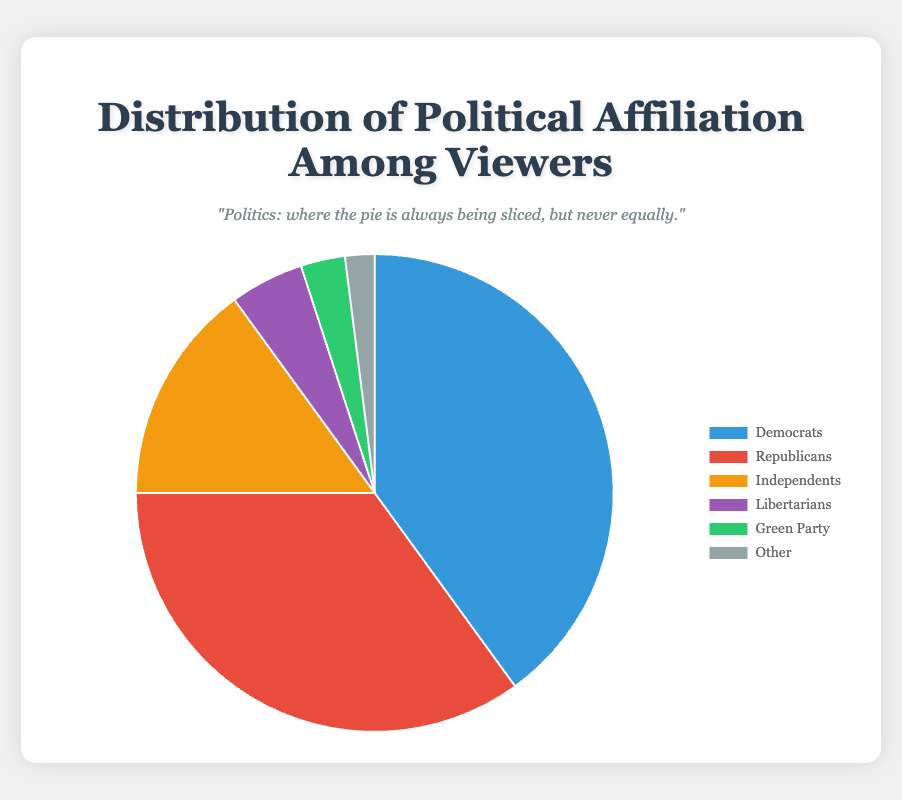Which political affiliation has the highest percentage of viewers? By observing the pie chart, the segment labeled "Democrats" takes up the largest proportion of the chart. Therefore, Democrats have the highest percentage of viewers.
Answer: Democrats Which political affiliation has the lowest percentage of viewers? The smallest segment in the pie chart is labeled "Other," indicating that it has the lowest percentage of viewers.
Answer: Other What is the combined percentage of viewers who identify as Independents or Libertarians? The percentage for Independents is 15%, and for Libertarians, it is 5%. Adding these together, we get 15 + 5 = 20%.
Answer: 20% How much greater is the percentage of Democrats compared to Republicans? The Democrats have a 40% share, and the Republicans have a 35% share. The difference is 40 - 35 = 5%.
Answer: 5% What is the total percentage of viewers that do not identify as Democrats or Republicans? To find the percentage of viewers who are not Democrats or Republicans, add the percentages of Independents, Libertarians, Green Party, and Other: 15% + 5% + 3% + 2% = 25%.
Answer: 25% What percentage of the viewers identify with the Green Party or Other? Add the percentages for the Green Party and Other: 3% + 2% = 5%.
Answer: 5% Is the percentage of Independents greater than the combined percentage of Libertarians and the Green Party? The percentage of Independents is 15%. The combined percentage of Libertarians and the Green Party is 5% + 3% = 8%. Since 15% is more than 8%, the percentage of Independents is indeed greater.
Answer: Yes Among the affiliations, which one has a 5% viewer base? By looking at the pie chart, the segment representing Libertarians shows them having a 5% viewer base.
Answer: Libertarians How many affiliations have less than a 10% share? By observing the chart, Libertarians (5%), Green Party (3%), and Other (2%) each have less than a 10% share. That makes 3 affiliations in total.
Answer: 3 